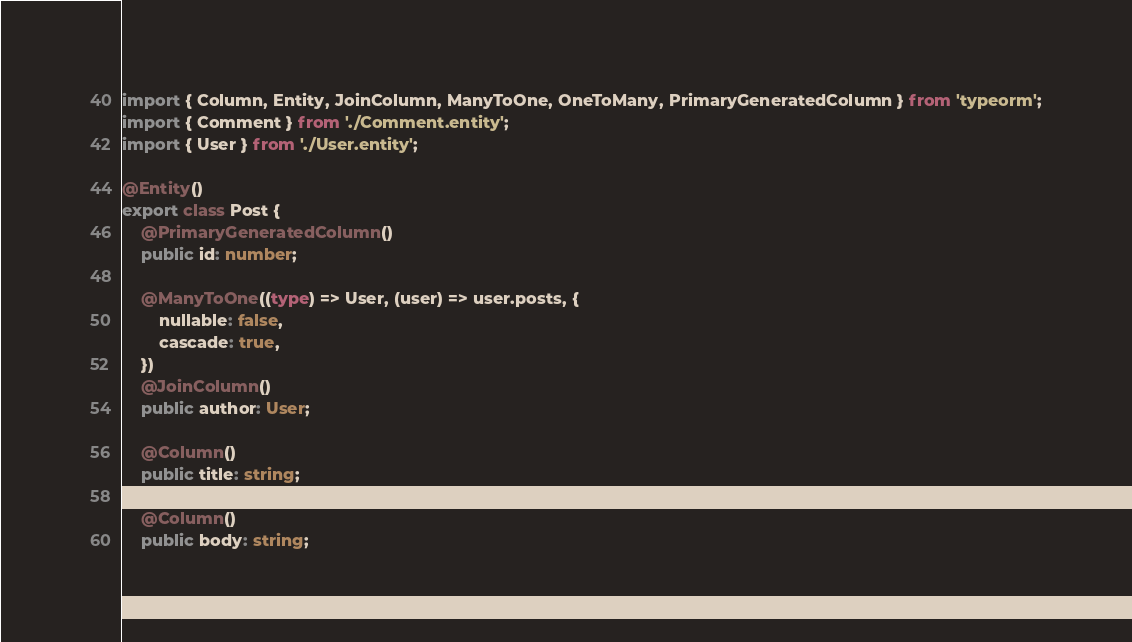Convert code to text. <code><loc_0><loc_0><loc_500><loc_500><_TypeScript_>import { Column, Entity, JoinColumn, ManyToOne, OneToMany, PrimaryGeneratedColumn } from 'typeorm';
import { Comment } from './Comment.entity';
import { User } from './User.entity';

@Entity()
export class Post {
    @PrimaryGeneratedColumn()
    public id: number;

    @ManyToOne((type) => User, (user) => user.posts, {
        nullable: false,
        cascade: true,
    })
    @JoinColumn()
    public author: User;

    @Column()
    public title: string;

    @Column()
    public body: string;
</code> 